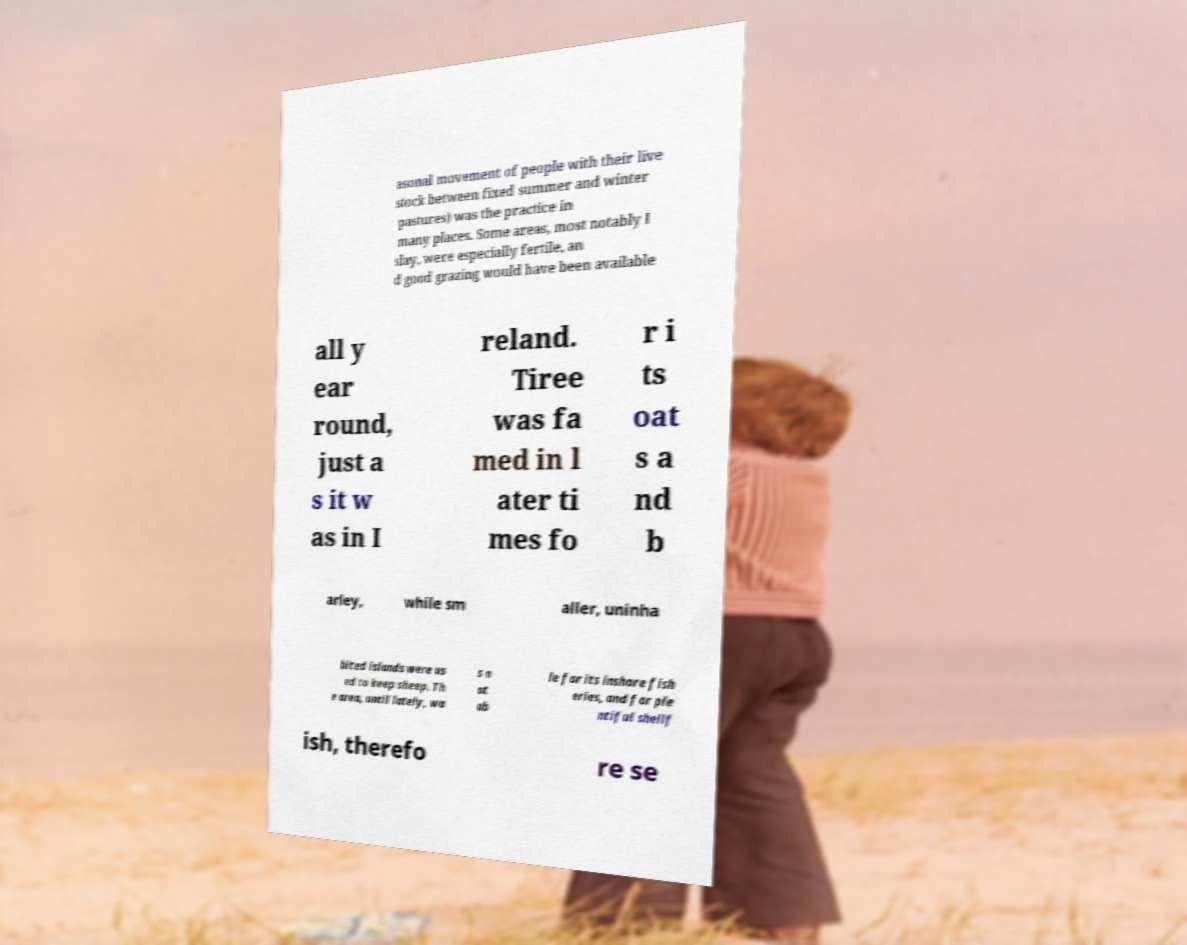Please read and relay the text visible in this image. What does it say? asonal movement of people with their live stock between fixed summer and winter pastures) was the practice in many places. Some areas, most notably I slay, were especially fertile, an d good grazing would have been available all y ear round, just a s it w as in I reland. Tiree was fa med in l ater ti mes fo r i ts oat s a nd b arley, while sm aller, uninha bited islands were us ed to keep sheep. Th e area, until lately, wa s n ot ab le for its inshore fish eries, and for ple ntiful shellf ish, therefo re se 